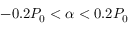<formula> <loc_0><loc_0><loc_500><loc_500>- 0 . 2 P _ { 0 } < \alpha < 0 . 2 P _ { 0 }</formula> 